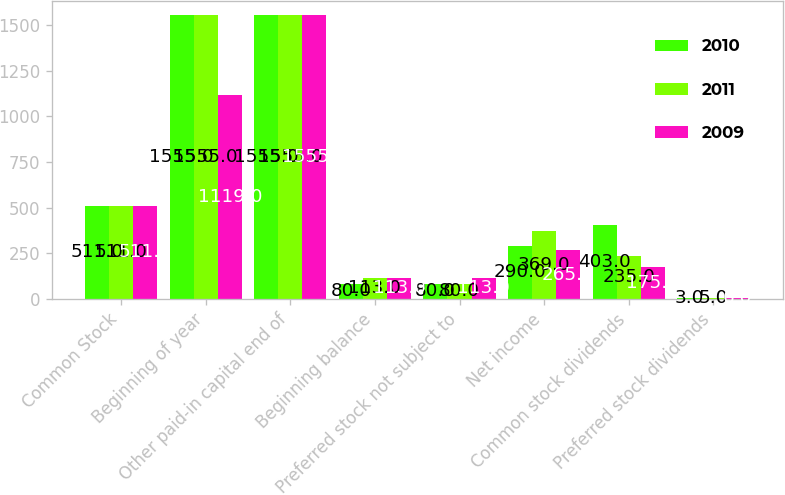Convert chart to OTSL. <chart><loc_0><loc_0><loc_500><loc_500><stacked_bar_chart><ecel><fcel>Common Stock<fcel>Beginning of year<fcel>Other paid-in capital end of<fcel>Beginning balance<fcel>Preferred stock not subject to<fcel>Net income<fcel>Common stock dividends<fcel>Preferred stock dividends<nl><fcel>2010<fcel>511<fcel>1555<fcel>1555<fcel>80<fcel>80<fcel>290<fcel>403<fcel>3<nl><fcel>2011<fcel>511<fcel>1555<fcel>1555<fcel>113<fcel>80<fcel>369<fcel>235<fcel>5<nl><fcel>2009<fcel>511<fcel>1119<fcel>1555<fcel>113<fcel>113<fcel>265<fcel>175<fcel>6<nl></chart> 